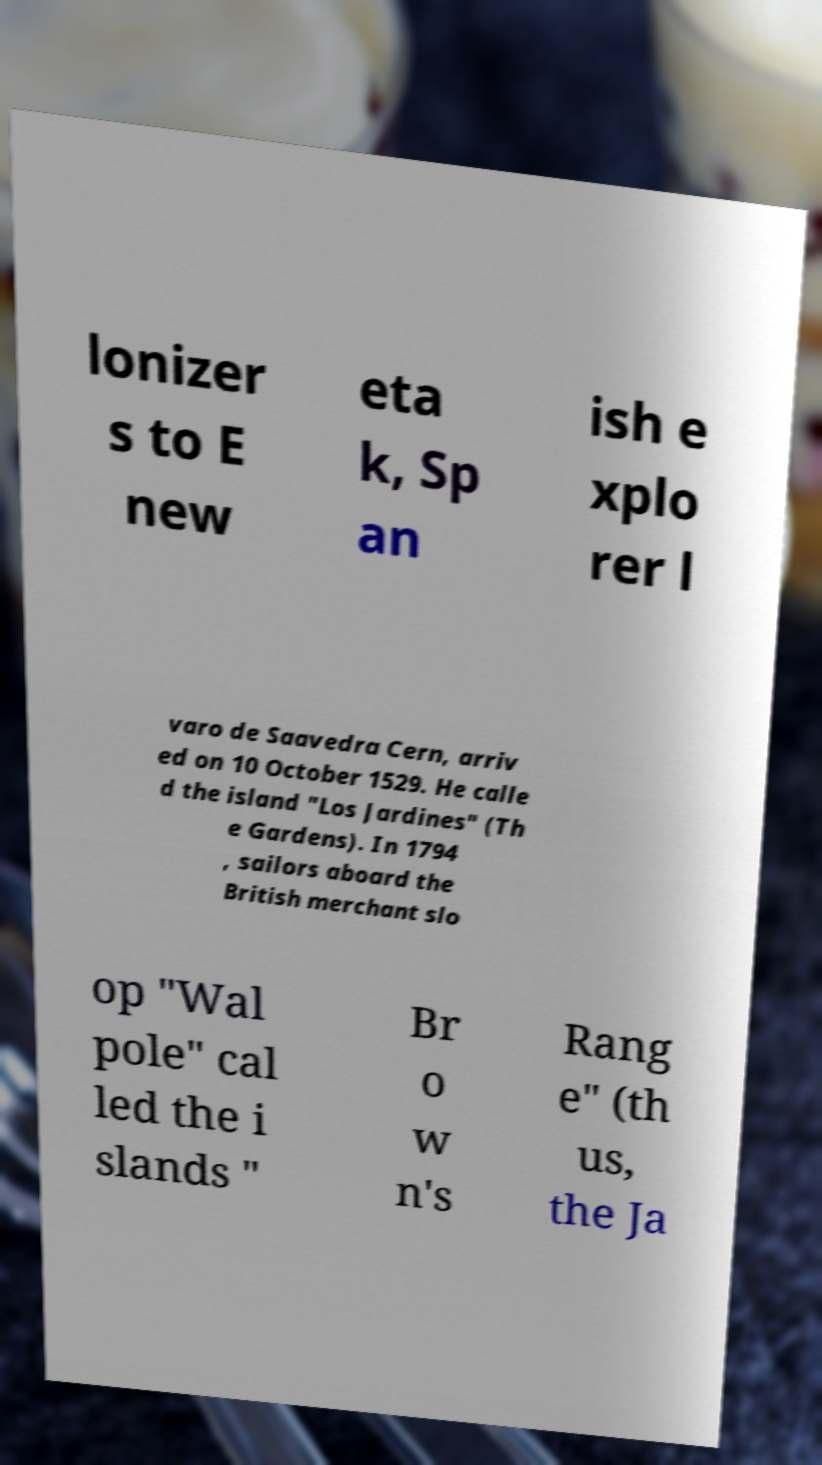Please read and relay the text visible in this image. What does it say? lonizer s to E new eta k, Sp an ish e xplo rer l varo de Saavedra Cern, arriv ed on 10 October 1529. He calle d the island "Los Jardines" (Th e Gardens). In 1794 , sailors aboard the British merchant slo op "Wal pole" cal led the i slands " Br o w n's Rang e" (th us, the Ja 